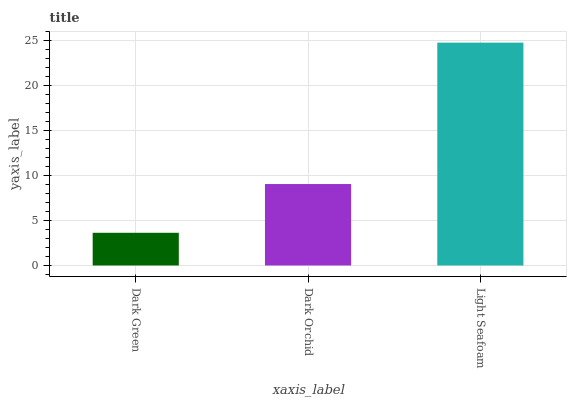Is Light Seafoam the maximum?
Answer yes or no. Yes. Is Dark Orchid the minimum?
Answer yes or no. No. Is Dark Orchid the maximum?
Answer yes or no. No. Is Dark Orchid greater than Dark Green?
Answer yes or no. Yes. Is Dark Green less than Dark Orchid?
Answer yes or no. Yes. Is Dark Green greater than Dark Orchid?
Answer yes or no. No. Is Dark Orchid less than Dark Green?
Answer yes or no. No. Is Dark Orchid the high median?
Answer yes or no. Yes. Is Dark Orchid the low median?
Answer yes or no. Yes. Is Dark Green the high median?
Answer yes or no. No. Is Light Seafoam the low median?
Answer yes or no. No. 